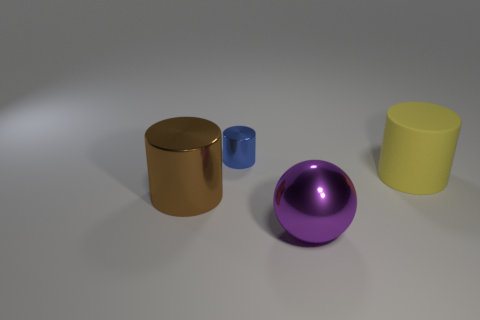Is there anything else that has the same material as the yellow cylinder?
Give a very brief answer. No. Is the number of purple matte cylinders less than the number of large yellow rubber cylinders?
Your response must be concise. Yes. There is a brown metal cylinder; are there any big brown objects on the left side of it?
Keep it short and to the point. No. Is the material of the purple thing the same as the large yellow cylinder?
Provide a succinct answer. No. What color is the small object that is the same shape as the big yellow rubber object?
Your response must be concise. Blue. Do the object behind the large yellow rubber cylinder and the matte object have the same color?
Ensure brevity in your answer.  No. How many purple spheres are the same material as the big brown cylinder?
Your answer should be very brief. 1. What number of large metallic cylinders are behind the purple thing?
Your response must be concise. 1. The brown object is what size?
Ensure brevity in your answer.  Large. There is another metallic thing that is the same size as the brown metal object; what color is it?
Keep it short and to the point. Purple. 